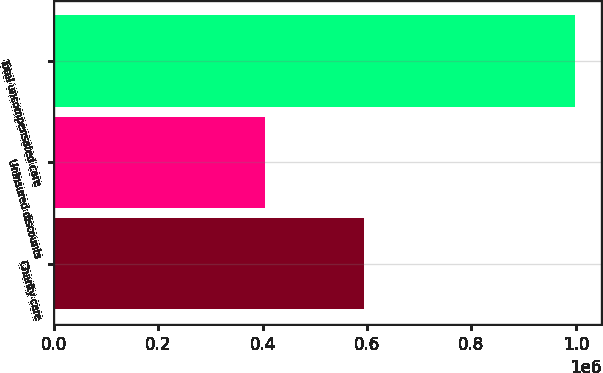Convert chart to OTSL. <chart><loc_0><loc_0><loc_500><loc_500><bar_chart><fcel>Charity care<fcel>Uninsured discounts<fcel>Total uncompensated care<nl><fcel>593474<fcel>405296<fcel>998770<nl></chart> 